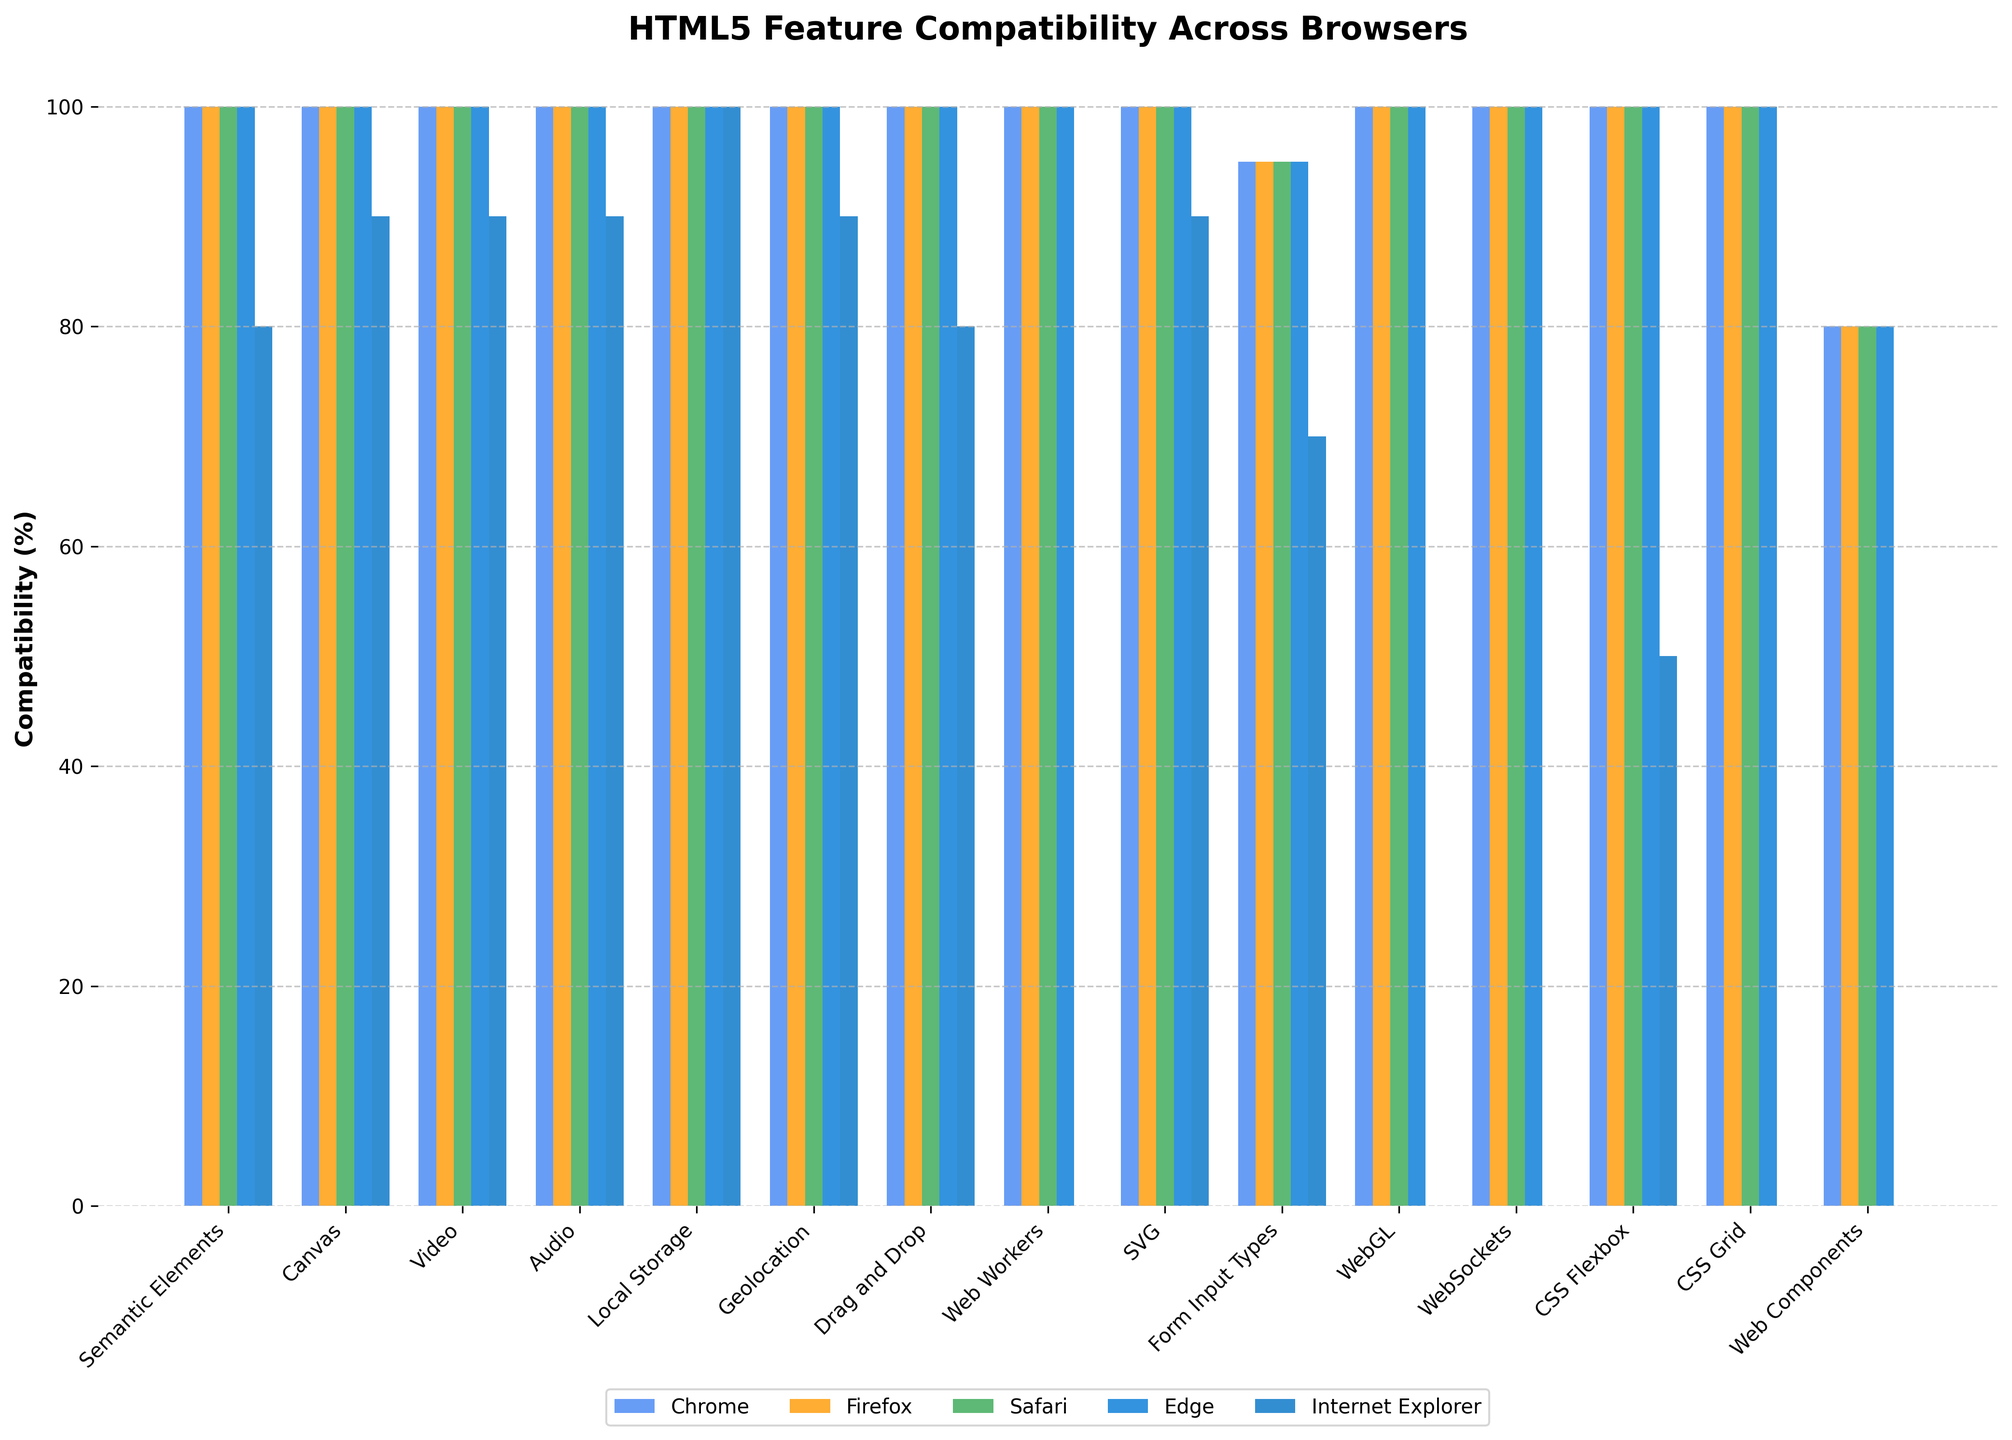Which feature has the lowest compatibility in Internet Explorer? By observing the height of the bars for Internet Explorer across all features, it's clear that 'Web Workers', 'WebGL', 'WebSockets', 'CSS Grid', and 'Web Components' have 0% compatibility.
Answer: Web Workers, WebGL, WebSockets, CSS Grid, Web Components Which feature has the highest compatibility in all browsers including Internet Explorer? By looking at the heights of the bars, 'Local Storage' is the only feature where all browsers including Internet Explorer have 100% compatibility.
Answer: Local Storage Which browser has the best overall compatibility with new HTML5 features? By checking the heights of the bars for each browser, Chrome, Firefox, Safari, and Edge all have consistently high bars across all features, indicating they all have high compatibility. There is no single browser that stands out among the four.
Answer: Chrome, Firefox, Safari, Edge Which HTML5 feature has the most uneven compatibility across all browsers? By comparing the differences in bar heights for each feature across the browsers, 'Web Components' shows significant variability because Internet Explorer has 0% compatibility while others are at 80%.
Answer: Web Components On average, how does Internet Explorer's compatibility compare to Chrome's? Sum of Internet Explorer compatibility percentages is (80+90+90+90+100+90+80+0+90+70+0+0+50+0+0) = 830. Average is 830/15 = 55.33%. Sum of Chrome compatibility percentages is (100+100+100+100+100+100+100+100+100+95+100+100+100+100+80) = 1475. Average is 1475/15 = 98.33%. Therefore, Chrome has a much higher average compatibility than Internet Explorer.
Answer: Chrome has a higher average compatibility Which HTML5 feature has 100% compatibility across four major browsers excluding Internet Explorer? By identifying the bars with full height for Chrome, Firefox, Safari, and Edge, 'Semantic Elements', 'Canvas', 'Video', 'Audio', 'Local Storage', 'Geolocation', 'Drag and Drop', 'SVG', 'WebGL' and 'WebSockets' all have 100% compatibility across these four browsers.
Answer: Several features; e.g., Semantic Elements, Canvas, Video, Audio, Local Storage.. Which feature shows a stark contrast between modern browsers and Internet Explorer, apart from zero compatibility features? By evaluating the significant differences in bar heights, 'CSS Flexbox' stands out in addition to the features with 0% compatibility on Internet Explorer as other major browsers have 100% while Internet Explorer has 50%.
Answer: CSS Flexbox 